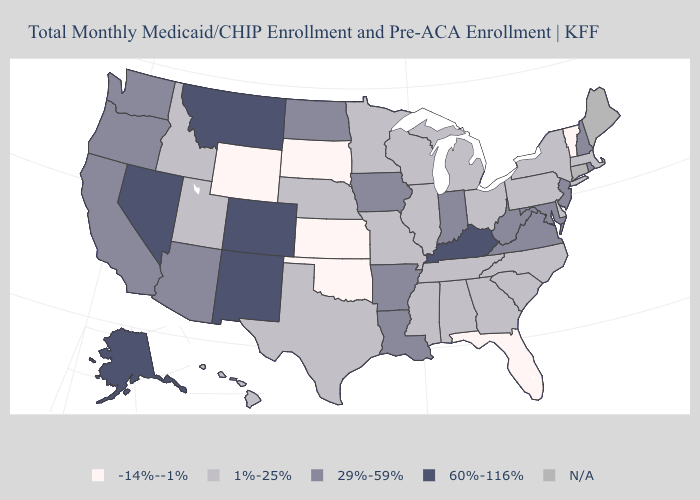Which states have the lowest value in the USA?
Answer briefly. Florida, Kansas, Oklahoma, South Dakota, Vermont, Wyoming. Name the states that have a value in the range 60%-116%?
Concise answer only. Alaska, Colorado, Kentucky, Montana, Nevada, New Mexico. Does the first symbol in the legend represent the smallest category?
Write a very short answer. Yes. Does the first symbol in the legend represent the smallest category?
Be succinct. Yes. Does Nevada have the highest value in the USA?
Concise answer only. Yes. What is the value of Nebraska?
Write a very short answer. 1%-25%. What is the lowest value in states that border Virginia?
Be succinct. 1%-25%. What is the highest value in states that border Nebraska?
Concise answer only. 60%-116%. Among the states that border New York , does Vermont have the lowest value?
Write a very short answer. Yes. What is the highest value in states that border North Carolina?
Concise answer only. 29%-59%. Name the states that have a value in the range -14%--1%?
Answer briefly. Florida, Kansas, Oklahoma, South Dakota, Vermont, Wyoming. Name the states that have a value in the range N/A?
Keep it brief. Connecticut, Maine. What is the value of Washington?
Concise answer only. 29%-59%. How many symbols are there in the legend?
Write a very short answer. 5. What is the value of Hawaii?
Give a very brief answer. 1%-25%. 